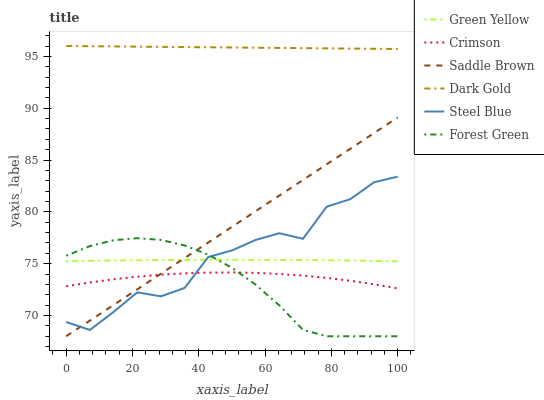Does Forest Green have the minimum area under the curve?
Answer yes or no. Yes. Does Dark Gold have the maximum area under the curve?
Answer yes or no. Yes. Does Steel Blue have the minimum area under the curve?
Answer yes or no. No. Does Steel Blue have the maximum area under the curve?
Answer yes or no. No. Is Dark Gold the smoothest?
Answer yes or no. Yes. Is Steel Blue the roughest?
Answer yes or no. Yes. Is Forest Green the smoothest?
Answer yes or no. No. Is Forest Green the roughest?
Answer yes or no. No. Does Steel Blue have the lowest value?
Answer yes or no. No. Does Dark Gold have the highest value?
Answer yes or no. Yes. Does Steel Blue have the highest value?
Answer yes or no. No. Is Steel Blue less than Dark Gold?
Answer yes or no. Yes. Is Dark Gold greater than Forest Green?
Answer yes or no. Yes. Does Steel Blue intersect Dark Gold?
Answer yes or no. No. 